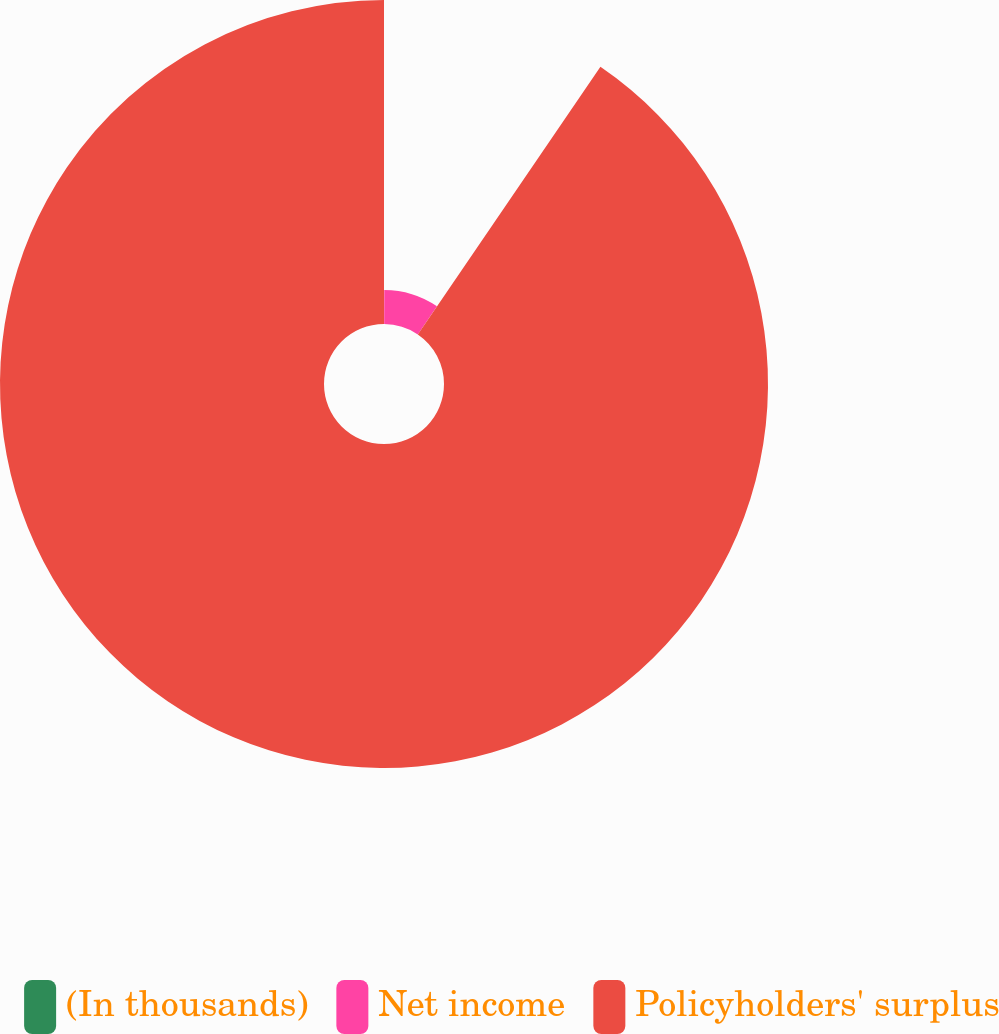<chart> <loc_0><loc_0><loc_500><loc_500><pie_chart><fcel>(In thousands)<fcel>Net income<fcel>Policyholders' surplus<nl><fcel>0.04%<fcel>9.49%<fcel>90.47%<nl></chart> 